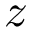Convert formula to latex. <formula><loc_0><loc_0><loc_500><loc_500>z</formula> 